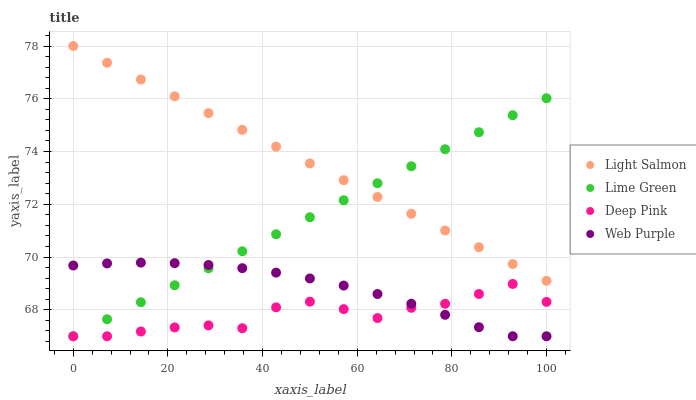Does Deep Pink have the minimum area under the curve?
Answer yes or no. Yes. Does Light Salmon have the maximum area under the curve?
Answer yes or no. Yes. Does Lime Green have the minimum area under the curve?
Answer yes or no. No. Does Lime Green have the maximum area under the curve?
Answer yes or no. No. Is Lime Green the smoothest?
Answer yes or no. Yes. Is Deep Pink the roughest?
Answer yes or no. Yes. Is Deep Pink the smoothest?
Answer yes or no. No. Is Lime Green the roughest?
Answer yes or no. No. Does Deep Pink have the lowest value?
Answer yes or no. Yes. Does Light Salmon have the highest value?
Answer yes or no. Yes. Does Lime Green have the highest value?
Answer yes or no. No. Is Web Purple less than Light Salmon?
Answer yes or no. Yes. Is Light Salmon greater than Deep Pink?
Answer yes or no. Yes. Does Deep Pink intersect Web Purple?
Answer yes or no. Yes. Is Deep Pink less than Web Purple?
Answer yes or no. No. Is Deep Pink greater than Web Purple?
Answer yes or no. No. Does Web Purple intersect Light Salmon?
Answer yes or no. No. 